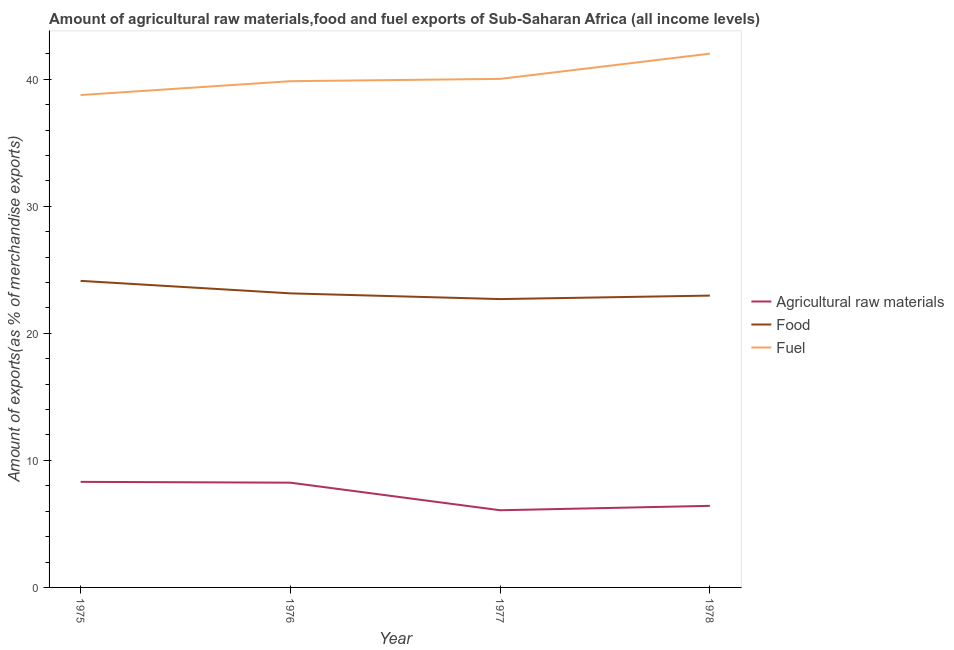How many different coloured lines are there?
Provide a short and direct response. 3. Does the line corresponding to percentage of raw materials exports intersect with the line corresponding to percentage of fuel exports?
Offer a terse response. No. Is the number of lines equal to the number of legend labels?
Your response must be concise. Yes. What is the percentage of food exports in 1976?
Ensure brevity in your answer.  23.15. Across all years, what is the maximum percentage of raw materials exports?
Provide a short and direct response. 8.31. Across all years, what is the minimum percentage of food exports?
Provide a short and direct response. 22.7. In which year was the percentage of fuel exports maximum?
Ensure brevity in your answer.  1978. What is the total percentage of food exports in the graph?
Provide a succinct answer. 92.94. What is the difference between the percentage of food exports in 1975 and that in 1978?
Offer a very short reply. 1.16. What is the difference between the percentage of fuel exports in 1975 and the percentage of food exports in 1978?
Provide a short and direct response. 15.79. What is the average percentage of food exports per year?
Keep it short and to the point. 23.23. In the year 1978, what is the difference between the percentage of fuel exports and percentage of raw materials exports?
Provide a short and direct response. 35.59. What is the ratio of the percentage of raw materials exports in 1976 to that in 1978?
Your response must be concise. 1.28. Is the difference between the percentage of raw materials exports in 1977 and 1978 greater than the difference between the percentage of fuel exports in 1977 and 1978?
Offer a terse response. Yes. What is the difference between the highest and the second highest percentage of fuel exports?
Offer a very short reply. 1.99. What is the difference between the highest and the lowest percentage of fuel exports?
Your answer should be compact. 3.26. Is it the case that in every year, the sum of the percentage of raw materials exports and percentage of food exports is greater than the percentage of fuel exports?
Offer a very short reply. No. Is the percentage of food exports strictly greater than the percentage of fuel exports over the years?
Make the answer very short. No. Is the percentage of raw materials exports strictly less than the percentage of fuel exports over the years?
Offer a terse response. Yes. How many lines are there?
Keep it short and to the point. 3. What is the difference between two consecutive major ticks on the Y-axis?
Your answer should be compact. 10. Does the graph contain any zero values?
Provide a short and direct response. No. Does the graph contain grids?
Keep it short and to the point. No. What is the title of the graph?
Give a very brief answer. Amount of agricultural raw materials,food and fuel exports of Sub-Saharan Africa (all income levels). Does "Tertiary" appear as one of the legend labels in the graph?
Offer a very short reply. No. What is the label or title of the X-axis?
Provide a short and direct response. Year. What is the label or title of the Y-axis?
Provide a succinct answer. Amount of exports(as % of merchandise exports). What is the Amount of exports(as % of merchandise exports) in Agricultural raw materials in 1975?
Provide a succinct answer. 8.31. What is the Amount of exports(as % of merchandise exports) in Food in 1975?
Your answer should be compact. 24.13. What is the Amount of exports(as % of merchandise exports) in Fuel in 1975?
Ensure brevity in your answer.  38.75. What is the Amount of exports(as % of merchandise exports) in Agricultural raw materials in 1976?
Provide a succinct answer. 8.24. What is the Amount of exports(as % of merchandise exports) of Food in 1976?
Make the answer very short. 23.15. What is the Amount of exports(as % of merchandise exports) of Fuel in 1976?
Provide a short and direct response. 39.85. What is the Amount of exports(as % of merchandise exports) of Agricultural raw materials in 1977?
Offer a very short reply. 6.07. What is the Amount of exports(as % of merchandise exports) of Food in 1977?
Ensure brevity in your answer.  22.7. What is the Amount of exports(as % of merchandise exports) of Fuel in 1977?
Keep it short and to the point. 40.03. What is the Amount of exports(as % of merchandise exports) in Agricultural raw materials in 1978?
Your response must be concise. 6.42. What is the Amount of exports(as % of merchandise exports) of Food in 1978?
Offer a terse response. 22.97. What is the Amount of exports(as % of merchandise exports) of Fuel in 1978?
Offer a very short reply. 42.01. Across all years, what is the maximum Amount of exports(as % of merchandise exports) in Agricultural raw materials?
Ensure brevity in your answer.  8.31. Across all years, what is the maximum Amount of exports(as % of merchandise exports) of Food?
Keep it short and to the point. 24.13. Across all years, what is the maximum Amount of exports(as % of merchandise exports) of Fuel?
Provide a succinct answer. 42.01. Across all years, what is the minimum Amount of exports(as % of merchandise exports) in Agricultural raw materials?
Offer a terse response. 6.07. Across all years, what is the minimum Amount of exports(as % of merchandise exports) in Food?
Give a very brief answer. 22.7. Across all years, what is the minimum Amount of exports(as % of merchandise exports) in Fuel?
Offer a very short reply. 38.75. What is the total Amount of exports(as % of merchandise exports) in Agricultural raw materials in the graph?
Provide a succinct answer. 29.05. What is the total Amount of exports(as % of merchandise exports) of Food in the graph?
Your response must be concise. 92.94. What is the total Amount of exports(as % of merchandise exports) of Fuel in the graph?
Offer a terse response. 160.64. What is the difference between the Amount of exports(as % of merchandise exports) of Agricultural raw materials in 1975 and that in 1976?
Your answer should be very brief. 0.06. What is the difference between the Amount of exports(as % of merchandise exports) in Food in 1975 and that in 1976?
Your answer should be very brief. 0.98. What is the difference between the Amount of exports(as % of merchandise exports) in Fuel in 1975 and that in 1976?
Make the answer very short. -1.09. What is the difference between the Amount of exports(as % of merchandise exports) of Agricultural raw materials in 1975 and that in 1977?
Provide a short and direct response. 2.23. What is the difference between the Amount of exports(as % of merchandise exports) in Food in 1975 and that in 1977?
Ensure brevity in your answer.  1.43. What is the difference between the Amount of exports(as % of merchandise exports) in Fuel in 1975 and that in 1977?
Provide a short and direct response. -1.27. What is the difference between the Amount of exports(as % of merchandise exports) of Agricultural raw materials in 1975 and that in 1978?
Ensure brevity in your answer.  1.89. What is the difference between the Amount of exports(as % of merchandise exports) in Food in 1975 and that in 1978?
Keep it short and to the point. 1.16. What is the difference between the Amount of exports(as % of merchandise exports) of Fuel in 1975 and that in 1978?
Your answer should be very brief. -3.26. What is the difference between the Amount of exports(as % of merchandise exports) in Agricultural raw materials in 1976 and that in 1977?
Your answer should be very brief. 2.17. What is the difference between the Amount of exports(as % of merchandise exports) of Food in 1976 and that in 1977?
Offer a very short reply. 0.45. What is the difference between the Amount of exports(as % of merchandise exports) in Fuel in 1976 and that in 1977?
Provide a succinct answer. -0.18. What is the difference between the Amount of exports(as % of merchandise exports) in Agricultural raw materials in 1976 and that in 1978?
Give a very brief answer. 1.82. What is the difference between the Amount of exports(as % of merchandise exports) in Food in 1976 and that in 1978?
Offer a terse response. 0.18. What is the difference between the Amount of exports(as % of merchandise exports) of Fuel in 1976 and that in 1978?
Your response must be concise. -2.17. What is the difference between the Amount of exports(as % of merchandise exports) of Agricultural raw materials in 1977 and that in 1978?
Your response must be concise. -0.35. What is the difference between the Amount of exports(as % of merchandise exports) of Food in 1977 and that in 1978?
Keep it short and to the point. -0.27. What is the difference between the Amount of exports(as % of merchandise exports) of Fuel in 1977 and that in 1978?
Offer a very short reply. -1.99. What is the difference between the Amount of exports(as % of merchandise exports) of Agricultural raw materials in 1975 and the Amount of exports(as % of merchandise exports) of Food in 1976?
Provide a short and direct response. -14.84. What is the difference between the Amount of exports(as % of merchandise exports) in Agricultural raw materials in 1975 and the Amount of exports(as % of merchandise exports) in Fuel in 1976?
Offer a terse response. -31.54. What is the difference between the Amount of exports(as % of merchandise exports) in Food in 1975 and the Amount of exports(as % of merchandise exports) in Fuel in 1976?
Provide a short and direct response. -15.72. What is the difference between the Amount of exports(as % of merchandise exports) of Agricultural raw materials in 1975 and the Amount of exports(as % of merchandise exports) of Food in 1977?
Your answer should be compact. -14.39. What is the difference between the Amount of exports(as % of merchandise exports) in Agricultural raw materials in 1975 and the Amount of exports(as % of merchandise exports) in Fuel in 1977?
Ensure brevity in your answer.  -31.72. What is the difference between the Amount of exports(as % of merchandise exports) of Food in 1975 and the Amount of exports(as % of merchandise exports) of Fuel in 1977?
Provide a succinct answer. -15.9. What is the difference between the Amount of exports(as % of merchandise exports) of Agricultural raw materials in 1975 and the Amount of exports(as % of merchandise exports) of Food in 1978?
Keep it short and to the point. -14.66. What is the difference between the Amount of exports(as % of merchandise exports) in Agricultural raw materials in 1975 and the Amount of exports(as % of merchandise exports) in Fuel in 1978?
Offer a terse response. -33.7. What is the difference between the Amount of exports(as % of merchandise exports) of Food in 1975 and the Amount of exports(as % of merchandise exports) of Fuel in 1978?
Ensure brevity in your answer.  -17.88. What is the difference between the Amount of exports(as % of merchandise exports) of Agricultural raw materials in 1976 and the Amount of exports(as % of merchandise exports) of Food in 1977?
Offer a very short reply. -14.45. What is the difference between the Amount of exports(as % of merchandise exports) in Agricultural raw materials in 1976 and the Amount of exports(as % of merchandise exports) in Fuel in 1977?
Give a very brief answer. -31.78. What is the difference between the Amount of exports(as % of merchandise exports) in Food in 1976 and the Amount of exports(as % of merchandise exports) in Fuel in 1977?
Your answer should be very brief. -16.88. What is the difference between the Amount of exports(as % of merchandise exports) of Agricultural raw materials in 1976 and the Amount of exports(as % of merchandise exports) of Food in 1978?
Provide a short and direct response. -14.72. What is the difference between the Amount of exports(as % of merchandise exports) of Agricultural raw materials in 1976 and the Amount of exports(as % of merchandise exports) of Fuel in 1978?
Your answer should be compact. -33.77. What is the difference between the Amount of exports(as % of merchandise exports) of Food in 1976 and the Amount of exports(as % of merchandise exports) of Fuel in 1978?
Provide a succinct answer. -18.87. What is the difference between the Amount of exports(as % of merchandise exports) of Agricultural raw materials in 1977 and the Amount of exports(as % of merchandise exports) of Food in 1978?
Provide a succinct answer. -16.89. What is the difference between the Amount of exports(as % of merchandise exports) in Agricultural raw materials in 1977 and the Amount of exports(as % of merchandise exports) in Fuel in 1978?
Ensure brevity in your answer.  -35.94. What is the difference between the Amount of exports(as % of merchandise exports) in Food in 1977 and the Amount of exports(as % of merchandise exports) in Fuel in 1978?
Ensure brevity in your answer.  -19.32. What is the average Amount of exports(as % of merchandise exports) of Agricultural raw materials per year?
Keep it short and to the point. 7.26. What is the average Amount of exports(as % of merchandise exports) in Food per year?
Your response must be concise. 23.23. What is the average Amount of exports(as % of merchandise exports) in Fuel per year?
Offer a very short reply. 40.16. In the year 1975, what is the difference between the Amount of exports(as % of merchandise exports) of Agricultural raw materials and Amount of exports(as % of merchandise exports) of Food?
Give a very brief answer. -15.82. In the year 1975, what is the difference between the Amount of exports(as % of merchandise exports) of Agricultural raw materials and Amount of exports(as % of merchandise exports) of Fuel?
Your answer should be very brief. -30.45. In the year 1975, what is the difference between the Amount of exports(as % of merchandise exports) in Food and Amount of exports(as % of merchandise exports) in Fuel?
Your response must be concise. -14.63. In the year 1976, what is the difference between the Amount of exports(as % of merchandise exports) of Agricultural raw materials and Amount of exports(as % of merchandise exports) of Food?
Your answer should be compact. -14.9. In the year 1976, what is the difference between the Amount of exports(as % of merchandise exports) of Agricultural raw materials and Amount of exports(as % of merchandise exports) of Fuel?
Keep it short and to the point. -31.6. In the year 1976, what is the difference between the Amount of exports(as % of merchandise exports) of Food and Amount of exports(as % of merchandise exports) of Fuel?
Ensure brevity in your answer.  -16.7. In the year 1977, what is the difference between the Amount of exports(as % of merchandise exports) of Agricultural raw materials and Amount of exports(as % of merchandise exports) of Food?
Give a very brief answer. -16.62. In the year 1977, what is the difference between the Amount of exports(as % of merchandise exports) of Agricultural raw materials and Amount of exports(as % of merchandise exports) of Fuel?
Your answer should be very brief. -33.95. In the year 1977, what is the difference between the Amount of exports(as % of merchandise exports) of Food and Amount of exports(as % of merchandise exports) of Fuel?
Provide a short and direct response. -17.33. In the year 1978, what is the difference between the Amount of exports(as % of merchandise exports) in Agricultural raw materials and Amount of exports(as % of merchandise exports) in Food?
Make the answer very short. -16.55. In the year 1978, what is the difference between the Amount of exports(as % of merchandise exports) of Agricultural raw materials and Amount of exports(as % of merchandise exports) of Fuel?
Your answer should be compact. -35.59. In the year 1978, what is the difference between the Amount of exports(as % of merchandise exports) of Food and Amount of exports(as % of merchandise exports) of Fuel?
Provide a succinct answer. -19.04. What is the ratio of the Amount of exports(as % of merchandise exports) in Agricultural raw materials in 1975 to that in 1976?
Provide a succinct answer. 1.01. What is the ratio of the Amount of exports(as % of merchandise exports) in Food in 1975 to that in 1976?
Offer a very short reply. 1.04. What is the ratio of the Amount of exports(as % of merchandise exports) of Fuel in 1975 to that in 1976?
Give a very brief answer. 0.97. What is the ratio of the Amount of exports(as % of merchandise exports) in Agricultural raw materials in 1975 to that in 1977?
Your response must be concise. 1.37. What is the ratio of the Amount of exports(as % of merchandise exports) in Food in 1975 to that in 1977?
Offer a terse response. 1.06. What is the ratio of the Amount of exports(as % of merchandise exports) of Fuel in 1975 to that in 1977?
Provide a short and direct response. 0.97. What is the ratio of the Amount of exports(as % of merchandise exports) of Agricultural raw materials in 1975 to that in 1978?
Offer a terse response. 1.29. What is the ratio of the Amount of exports(as % of merchandise exports) of Food in 1975 to that in 1978?
Give a very brief answer. 1.05. What is the ratio of the Amount of exports(as % of merchandise exports) in Fuel in 1975 to that in 1978?
Your answer should be very brief. 0.92. What is the ratio of the Amount of exports(as % of merchandise exports) in Agricultural raw materials in 1976 to that in 1977?
Your answer should be compact. 1.36. What is the ratio of the Amount of exports(as % of merchandise exports) in Food in 1976 to that in 1977?
Keep it short and to the point. 1.02. What is the ratio of the Amount of exports(as % of merchandise exports) of Agricultural raw materials in 1976 to that in 1978?
Your answer should be very brief. 1.28. What is the ratio of the Amount of exports(as % of merchandise exports) of Food in 1976 to that in 1978?
Offer a terse response. 1.01. What is the ratio of the Amount of exports(as % of merchandise exports) of Fuel in 1976 to that in 1978?
Ensure brevity in your answer.  0.95. What is the ratio of the Amount of exports(as % of merchandise exports) of Agricultural raw materials in 1977 to that in 1978?
Your response must be concise. 0.95. What is the ratio of the Amount of exports(as % of merchandise exports) of Fuel in 1977 to that in 1978?
Provide a short and direct response. 0.95. What is the difference between the highest and the second highest Amount of exports(as % of merchandise exports) of Agricultural raw materials?
Ensure brevity in your answer.  0.06. What is the difference between the highest and the second highest Amount of exports(as % of merchandise exports) of Food?
Your response must be concise. 0.98. What is the difference between the highest and the second highest Amount of exports(as % of merchandise exports) in Fuel?
Provide a succinct answer. 1.99. What is the difference between the highest and the lowest Amount of exports(as % of merchandise exports) in Agricultural raw materials?
Give a very brief answer. 2.23. What is the difference between the highest and the lowest Amount of exports(as % of merchandise exports) of Food?
Keep it short and to the point. 1.43. What is the difference between the highest and the lowest Amount of exports(as % of merchandise exports) in Fuel?
Offer a very short reply. 3.26. 